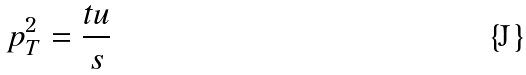<formula> <loc_0><loc_0><loc_500><loc_500>p _ { T } ^ { 2 } = \frac { t u } { s }</formula> 